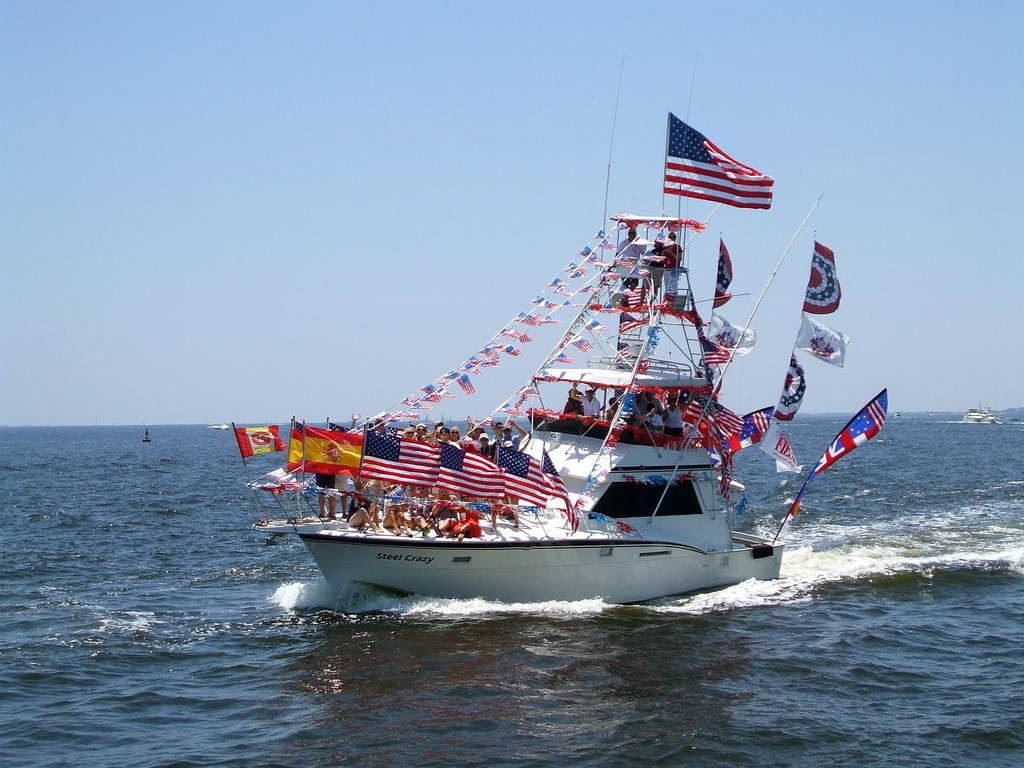Provide a one-sentence caption for the provided image. Ship with many flags on it and the words "Steel Crazy" on the bottom. 